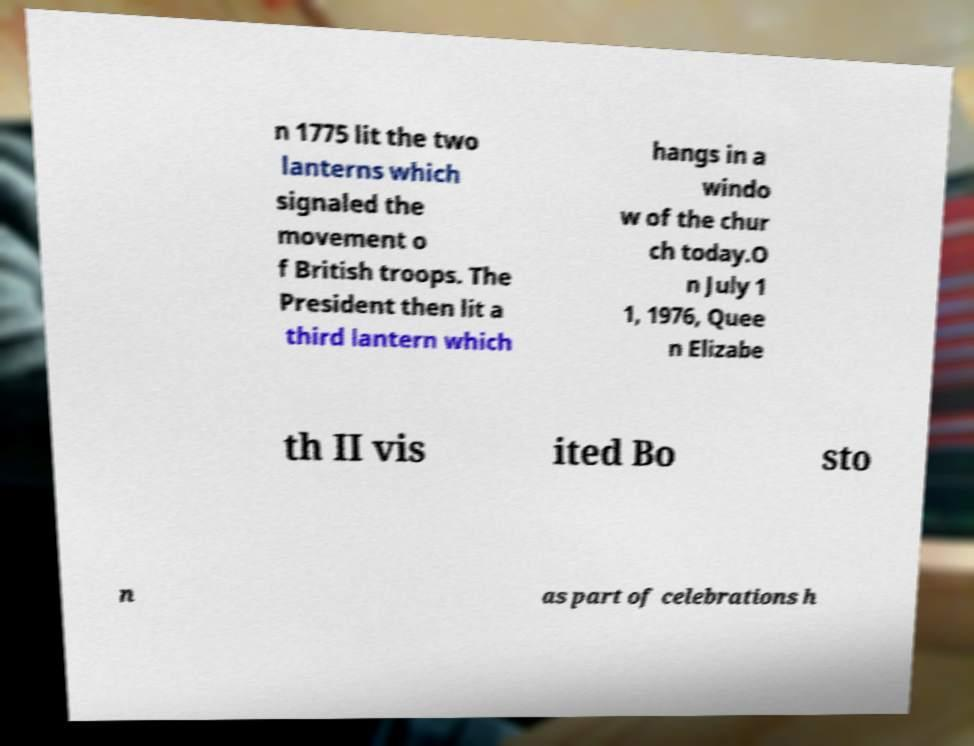Can you read and provide the text displayed in the image?This photo seems to have some interesting text. Can you extract and type it out for me? n 1775 lit the two lanterns which signaled the movement o f British troops. The President then lit a third lantern which hangs in a windo w of the chur ch today.O n July 1 1, 1976, Quee n Elizabe th II vis ited Bo sto n as part of celebrations h 